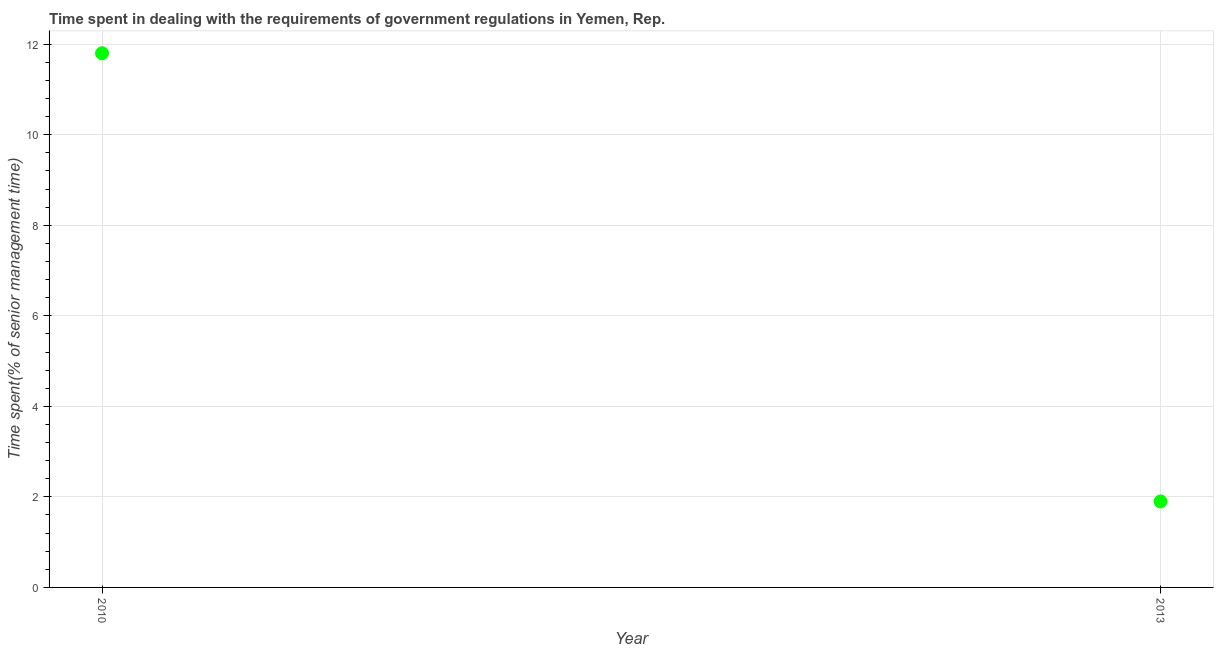Across all years, what is the minimum time spent in dealing with government regulations?
Keep it short and to the point. 1.9. What is the sum of the time spent in dealing with government regulations?
Ensure brevity in your answer.  13.7. What is the average time spent in dealing with government regulations per year?
Ensure brevity in your answer.  6.85. What is the median time spent in dealing with government regulations?
Your answer should be compact. 6.85. In how many years, is the time spent in dealing with government regulations greater than 5.6 %?
Provide a short and direct response. 1. Do a majority of the years between 2013 and 2010 (inclusive) have time spent in dealing with government regulations greater than 2.8 %?
Ensure brevity in your answer.  No. What is the ratio of the time spent in dealing with government regulations in 2010 to that in 2013?
Your answer should be compact. 6.21. Is the time spent in dealing with government regulations in 2010 less than that in 2013?
Your answer should be very brief. No. What is the title of the graph?
Your answer should be very brief. Time spent in dealing with the requirements of government regulations in Yemen, Rep. What is the label or title of the X-axis?
Your response must be concise. Year. What is the label or title of the Y-axis?
Your response must be concise. Time spent(% of senior management time). What is the Time spent(% of senior management time) in 2010?
Make the answer very short. 11.8. What is the difference between the Time spent(% of senior management time) in 2010 and 2013?
Make the answer very short. 9.9. What is the ratio of the Time spent(% of senior management time) in 2010 to that in 2013?
Your answer should be very brief. 6.21. 